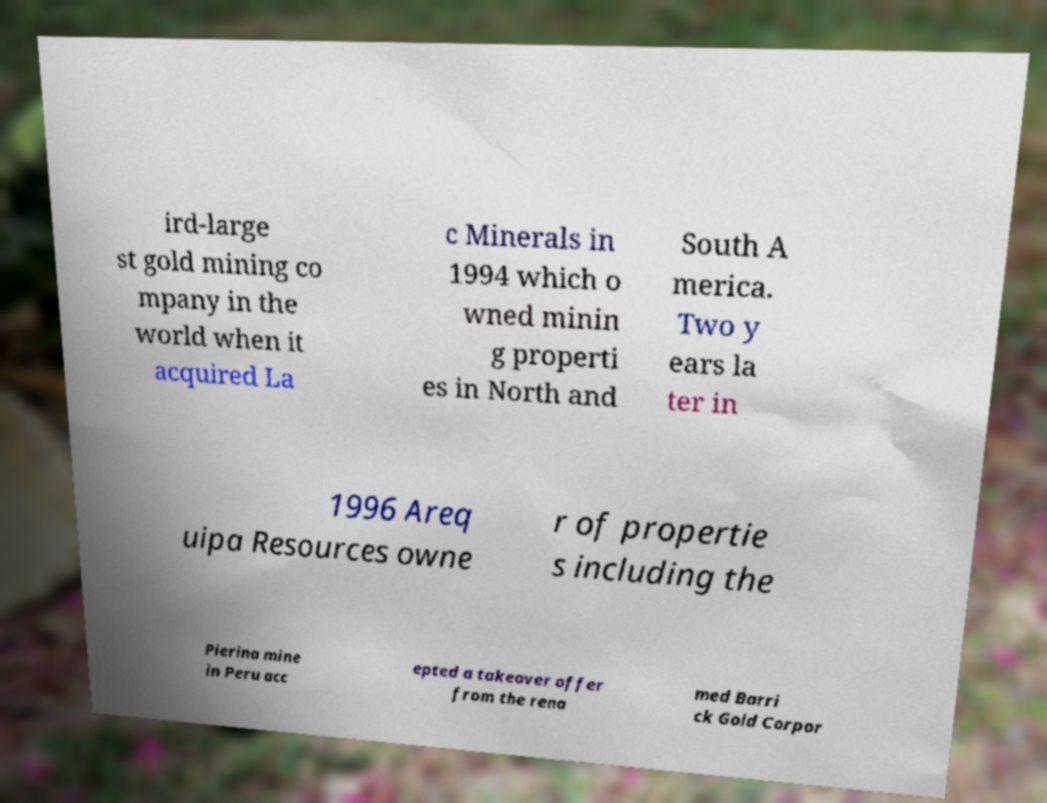Could you assist in decoding the text presented in this image and type it out clearly? ird-large st gold mining co mpany in the world when it acquired La c Minerals in 1994 which o wned minin g properti es in North and South A merica. Two y ears la ter in 1996 Areq uipa Resources owne r of propertie s including the Pierina mine in Peru acc epted a takeover offer from the rena med Barri ck Gold Corpor 